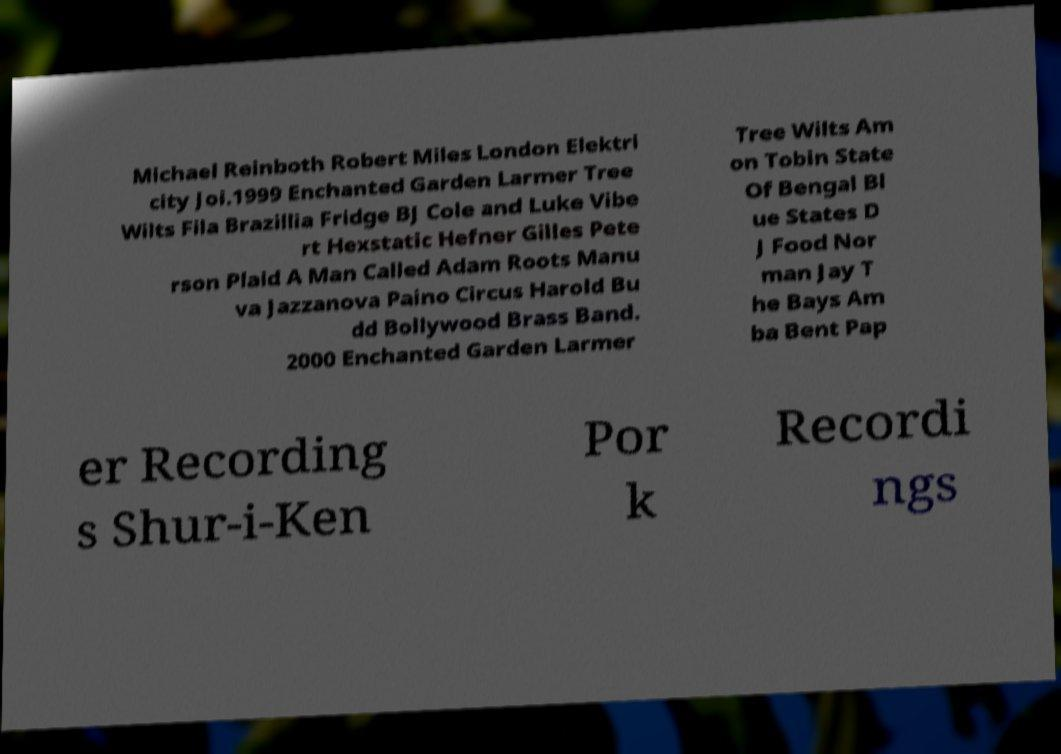There's text embedded in this image that I need extracted. Can you transcribe it verbatim? Michael Reinboth Robert Miles London Elektri city Joi.1999 Enchanted Garden Larmer Tree Wilts Fila Brazillia Fridge BJ Cole and Luke Vibe rt Hexstatic Hefner Gilles Pete rson Plaid A Man Called Adam Roots Manu va Jazzanova Paino Circus Harold Bu dd Bollywood Brass Band. 2000 Enchanted Garden Larmer Tree Wilts Am on Tobin State Of Bengal Bl ue States D J Food Nor man Jay T he Bays Am ba Bent Pap er Recording s Shur-i-Ken Por k Recordi ngs 